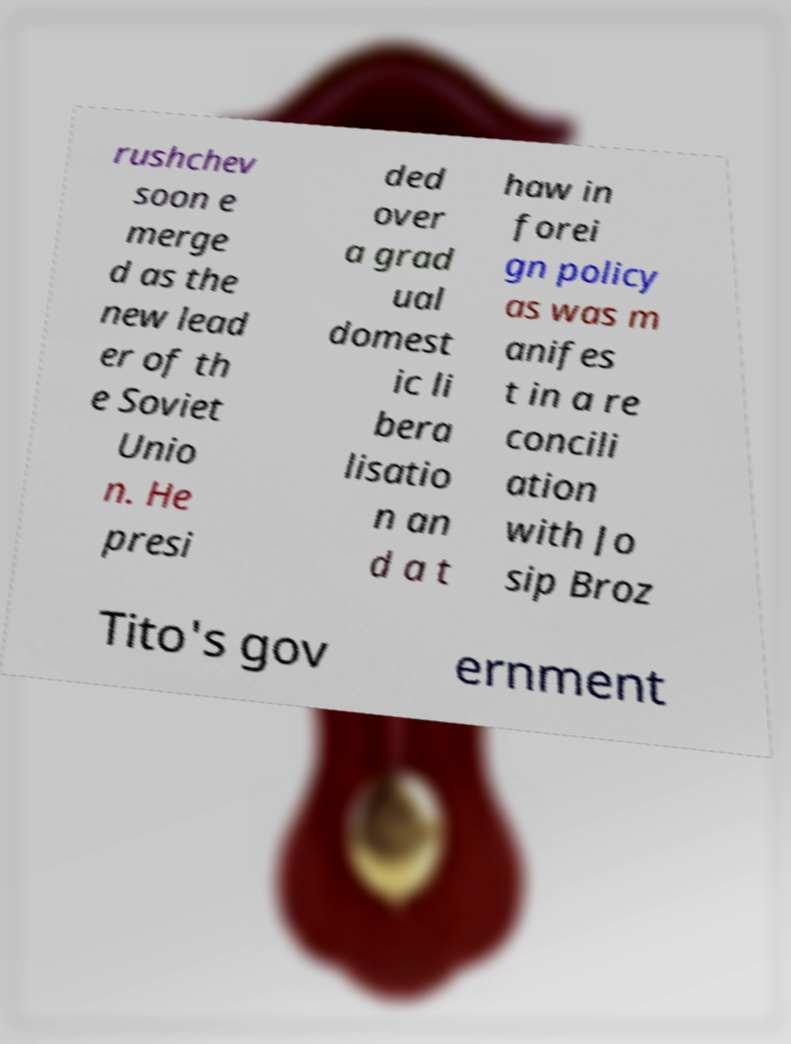Could you assist in decoding the text presented in this image and type it out clearly? rushchev soon e merge d as the new lead er of th e Soviet Unio n. He presi ded over a grad ual domest ic li bera lisatio n an d a t haw in forei gn policy as was m anifes t in a re concili ation with Jo sip Broz Tito's gov ernment 